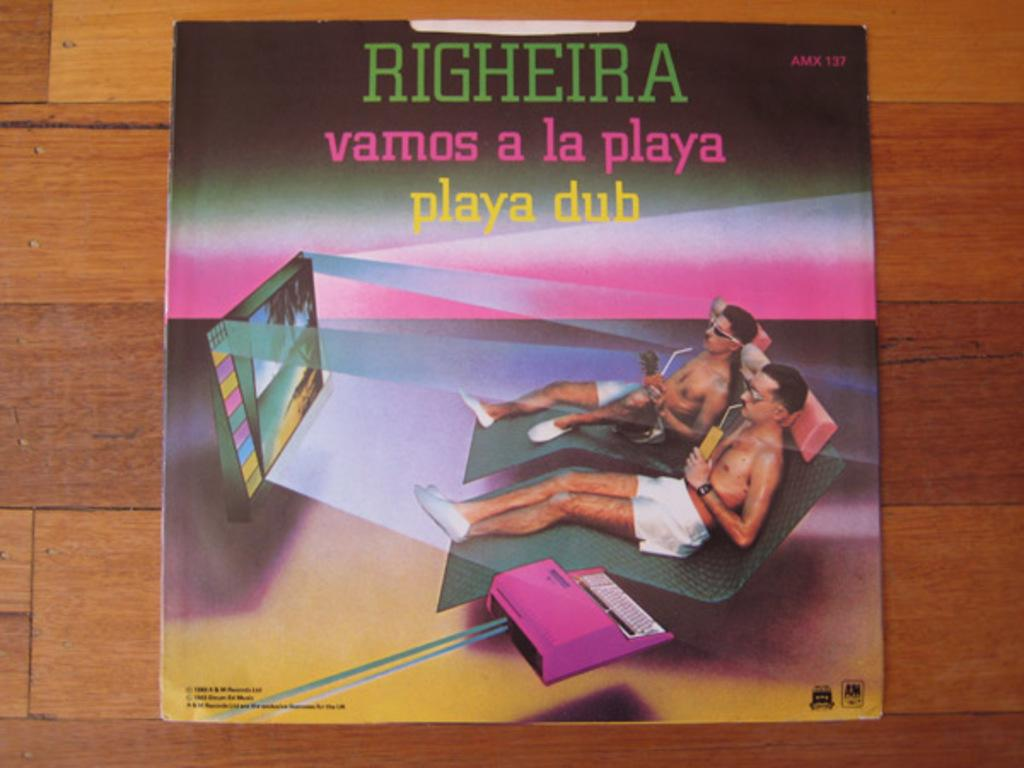<image>
Offer a succinct explanation of the picture presented. A cover that says Righeira at the top of it. 